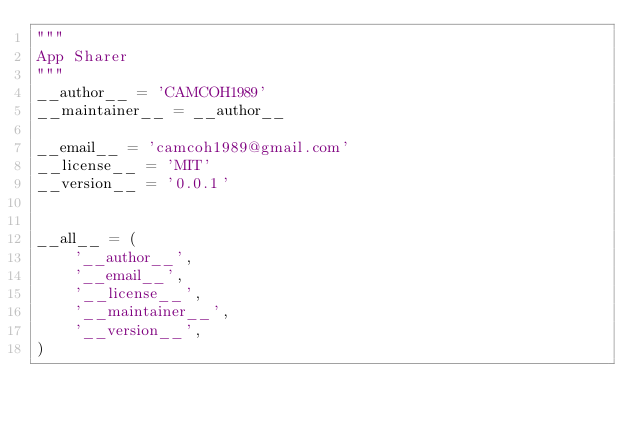Convert code to text. <code><loc_0><loc_0><loc_500><loc_500><_Python_>"""
App Sharer
"""
__author__ = 'CAMCOH1989'
__maintainer__ = __author__

__email__ = 'camcoh1989@gmail.com'
__license__ = 'MIT'
__version__ = '0.0.1'


__all__ = (
    '__author__',
    '__email__',
    '__license__',
    '__maintainer__',
    '__version__',
)
</code> 